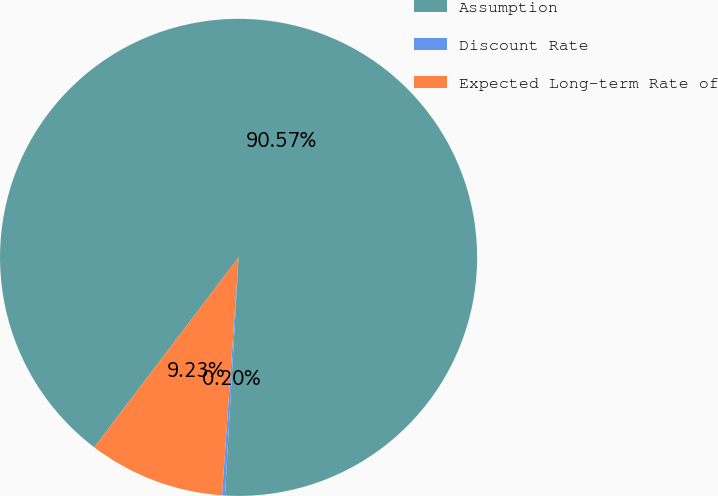<chart> <loc_0><loc_0><loc_500><loc_500><pie_chart><fcel>Assumption<fcel>Discount Rate<fcel>Expected Long-term Rate of<nl><fcel>90.57%<fcel>0.2%<fcel>9.23%<nl></chart> 